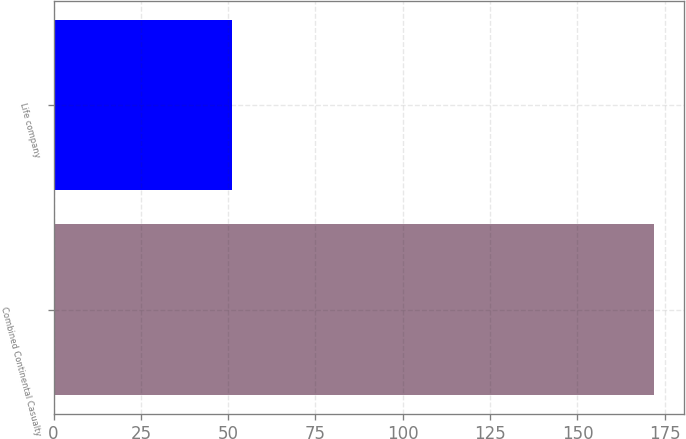<chart> <loc_0><loc_0><loc_500><loc_500><bar_chart><fcel>Combined Continental Casualty<fcel>Life company<nl><fcel>172<fcel>51<nl></chart> 